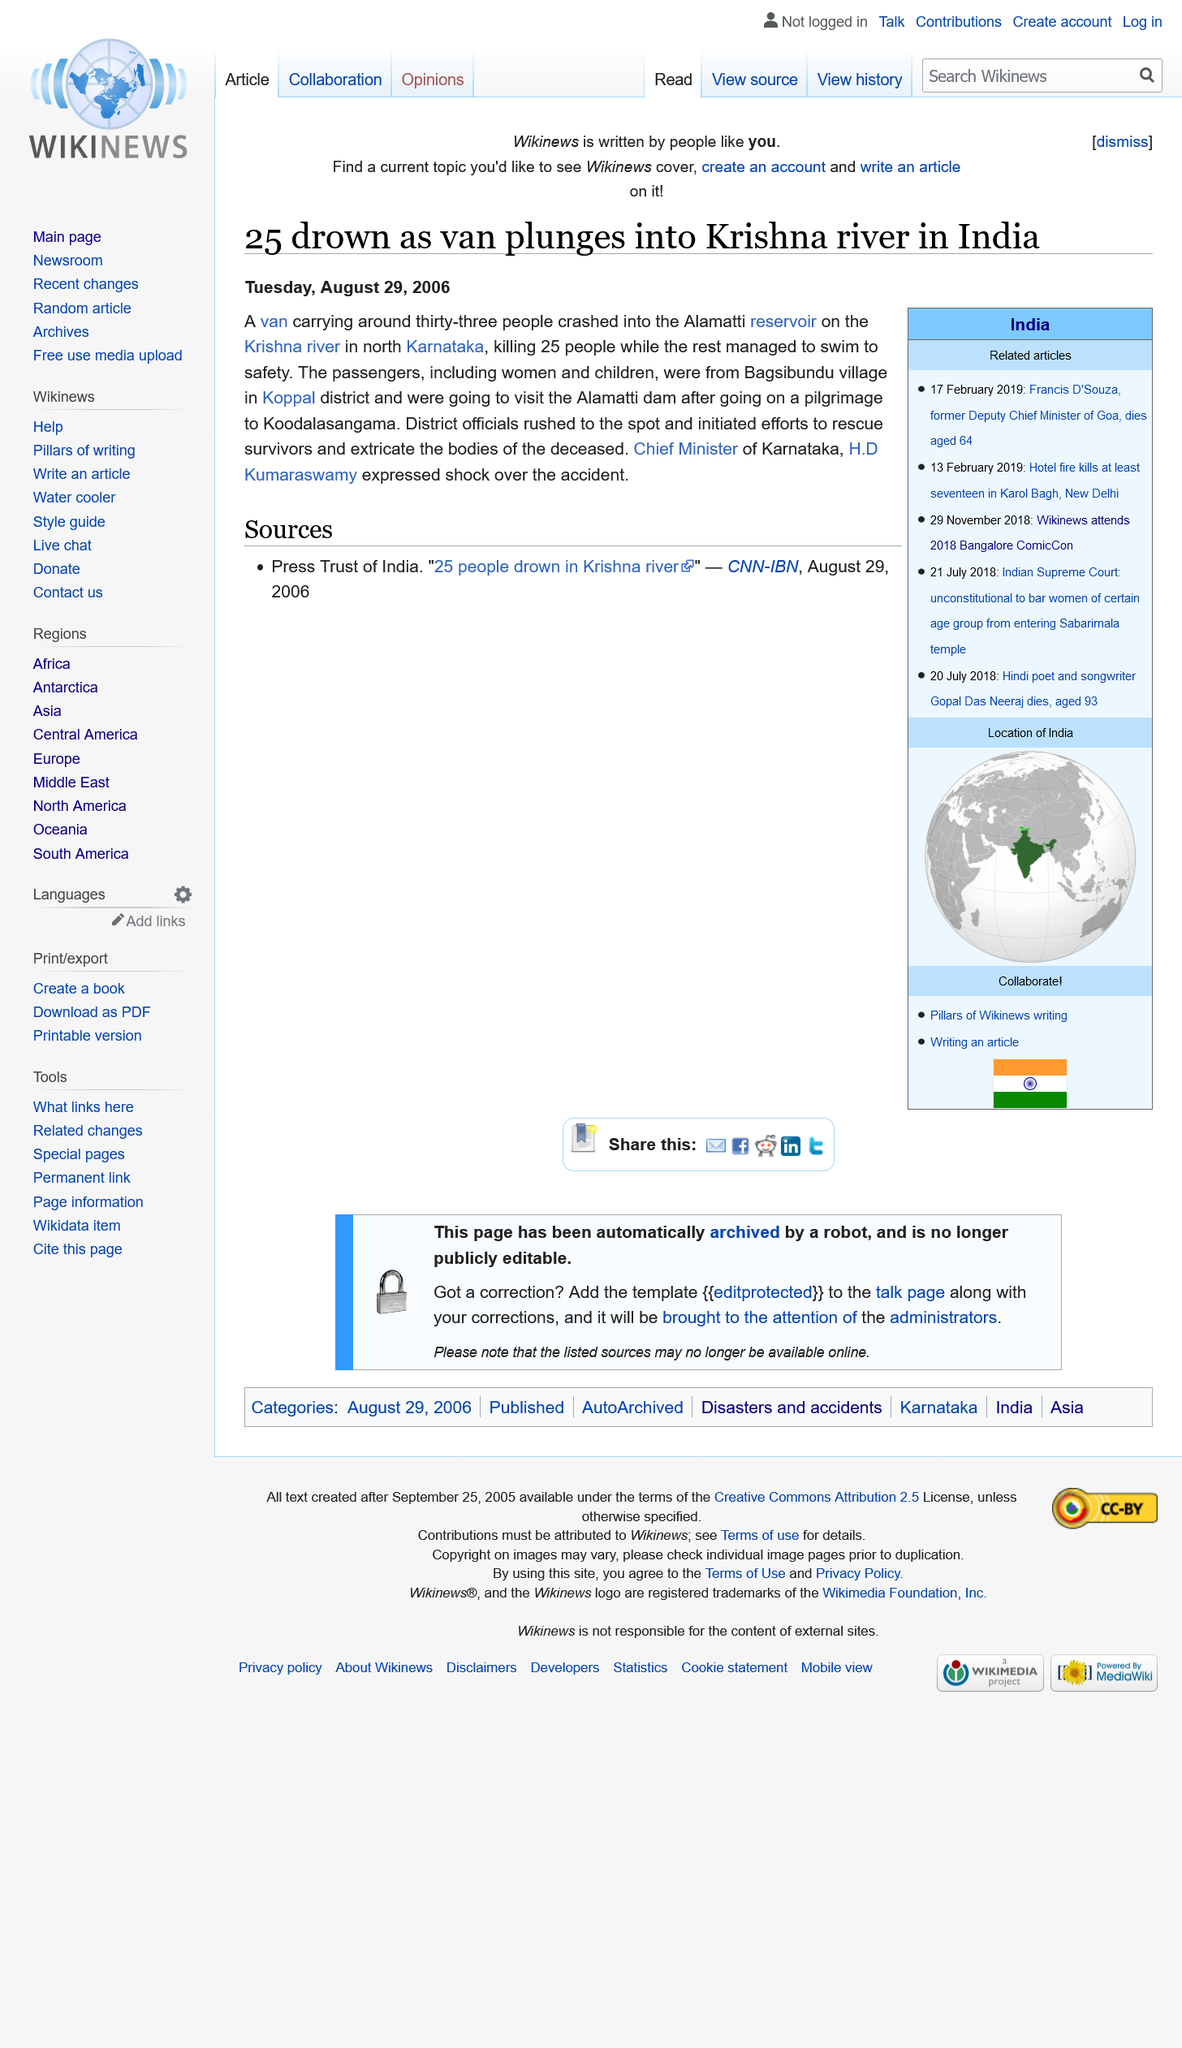Indicate a few pertinent items in this graphic. 25 people died when the van plunged into the Krishna river. Thirty-three people were in the van. The article "25 drown as van plunges into Krishna river in India" was published on Tuesday August 29, 2006. 